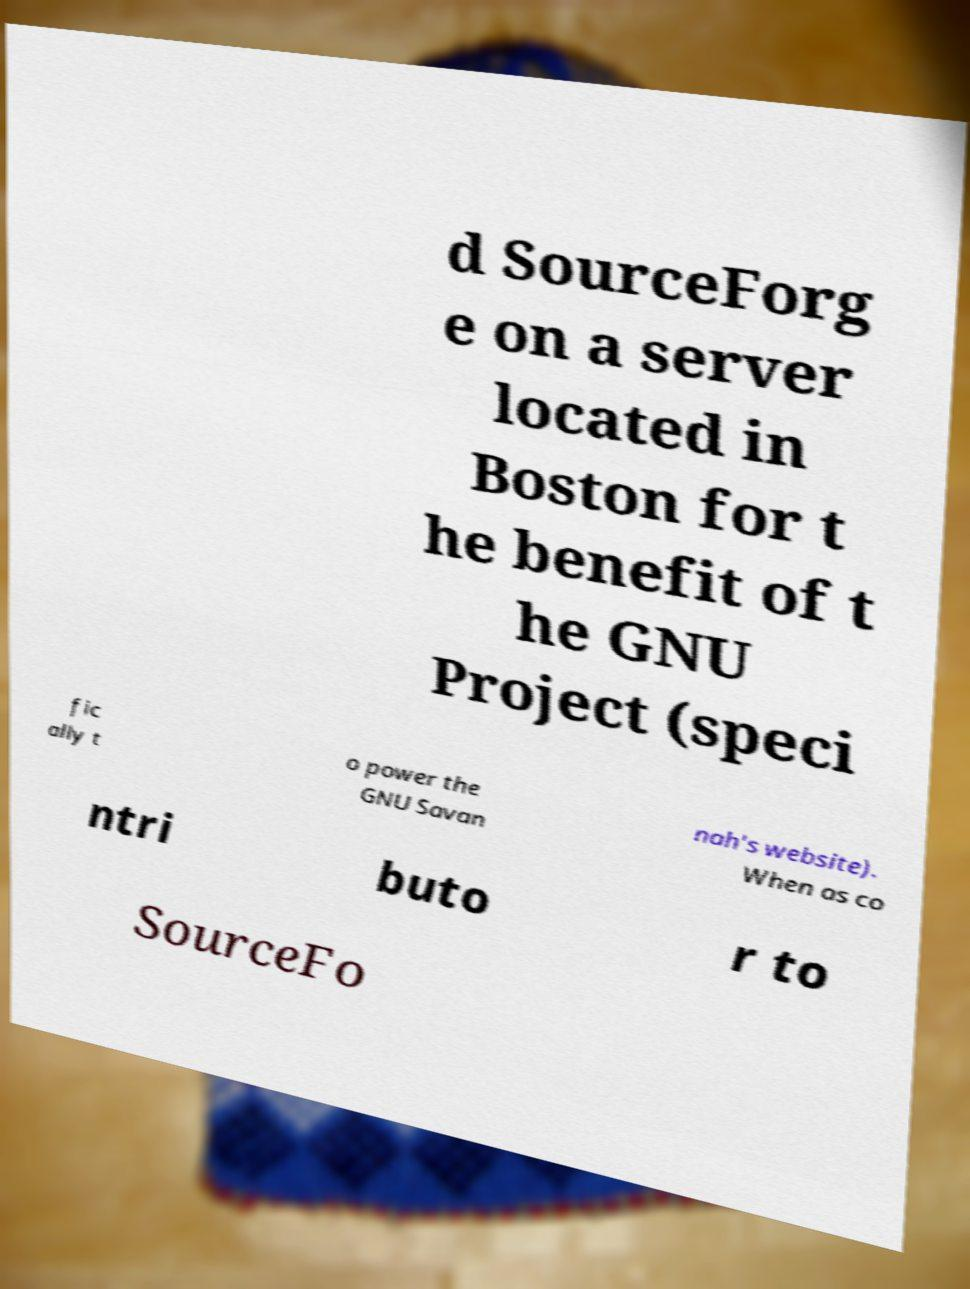Can you accurately transcribe the text from the provided image for me? d SourceForg e on a server located in Boston for t he benefit of t he GNU Project (speci fic ally t o power the GNU Savan nah's website). When as co ntri buto r to SourceFo 